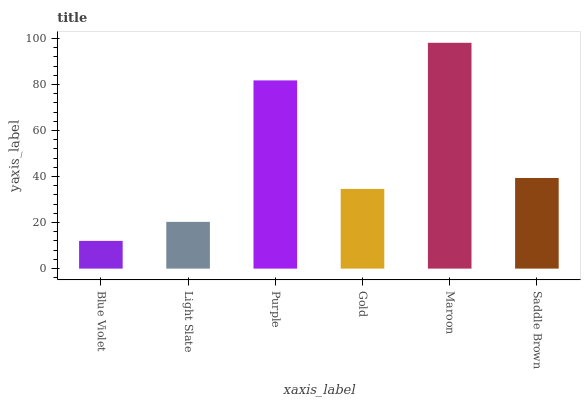Is Blue Violet the minimum?
Answer yes or no. Yes. Is Maroon the maximum?
Answer yes or no. Yes. Is Light Slate the minimum?
Answer yes or no. No. Is Light Slate the maximum?
Answer yes or no. No. Is Light Slate greater than Blue Violet?
Answer yes or no. Yes. Is Blue Violet less than Light Slate?
Answer yes or no. Yes. Is Blue Violet greater than Light Slate?
Answer yes or no. No. Is Light Slate less than Blue Violet?
Answer yes or no. No. Is Saddle Brown the high median?
Answer yes or no. Yes. Is Gold the low median?
Answer yes or no. Yes. Is Gold the high median?
Answer yes or no. No. Is Purple the low median?
Answer yes or no. No. 